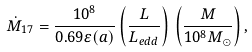Convert formula to latex. <formula><loc_0><loc_0><loc_500><loc_500>\dot { M } _ { 1 7 } = \frac { 1 0 ^ { 8 } } { 0 . 6 9 \varepsilon ( a ) } \left ( \frac { L } { L _ { e d d } } \right ) \, \left ( \frac { M } { 1 0 ^ { 8 } M _ { \odot } } \right ) ,</formula> 